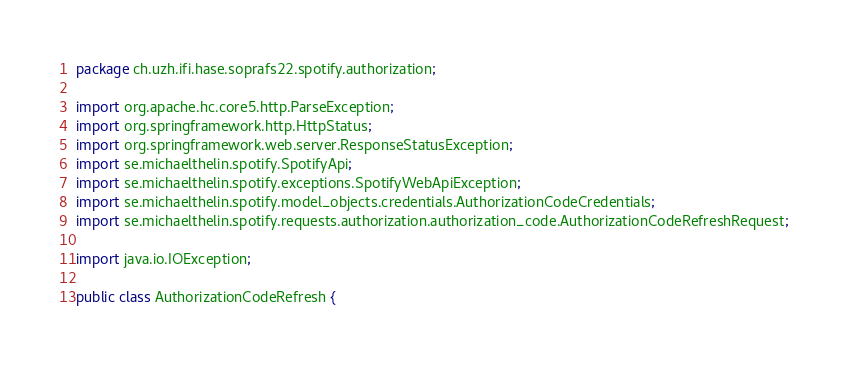<code> <loc_0><loc_0><loc_500><loc_500><_Java_>package ch.uzh.ifi.hase.soprafs22.spotify.authorization;

import org.apache.hc.core5.http.ParseException;
import org.springframework.http.HttpStatus;
import org.springframework.web.server.ResponseStatusException;
import se.michaelthelin.spotify.SpotifyApi;
import se.michaelthelin.spotify.exceptions.SpotifyWebApiException;
import se.michaelthelin.spotify.model_objects.credentials.AuthorizationCodeCredentials;
import se.michaelthelin.spotify.requests.authorization.authorization_code.AuthorizationCodeRefreshRequest;

import java.io.IOException;

public class AuthorizationCodeRefresh {
</code> 